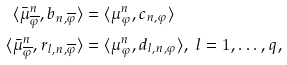<formula> <loc_0><loc_0><loc_500><loc_500>\langle \bar { \mu } ^ { n } _ { \overline { \varphi } } , b _ { n , \overline { \varphi } } \rangle & = \langle \mu ^ { n } _ { \varphi } , c _ { n , \varphi } \rangle \\ \langle \bar { \mu } ^ { n } _ { \overline { \varphi } } , r _ { l , n , \overline { \varphi } } \rangle & = \langle \mu ^ { n } _ { \varphi } , d _ { l , n , \varphi } \rangle , \text { } l = 1 , \dots , q ,</formula> 